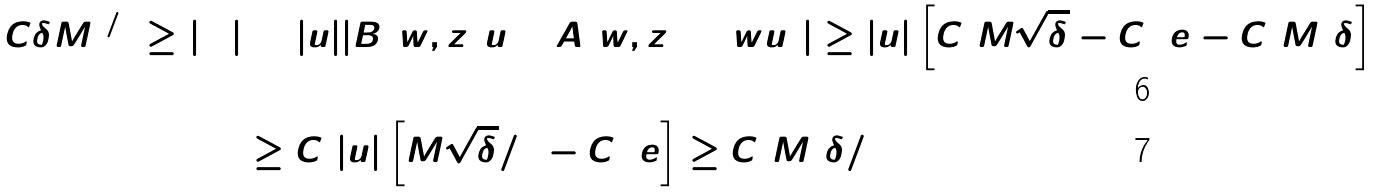<formula> <loc_0><loc_0><loc_500><loc_500>C \delta M ^ { 1 / 4 } \geq | \Upsilon | & = | u | | B ( w , z ) u + A ( w , z ) + w u ^ { 2 } | \geq | u | \left [ C _ { 1 } M \sqrt { \delta } - C _ { 2 } \ e - C _ { 3 } M ^ { 2 } \delta \right ] \\ & \geq C _ { 1 } | u | \left [ M \sqrt { \delta } / 2 - C _ { 2 } \ e \right ] \geq C _ { 1 } M ^ { 2 } \delta / 4</formula> 